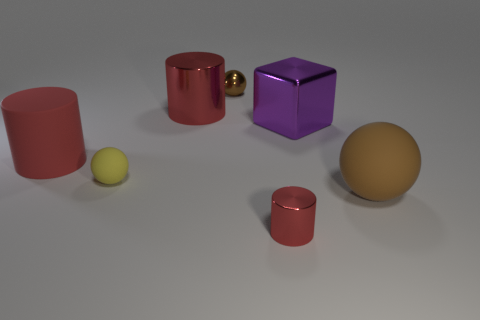Subtract all large red cylinders. How many cylinders are left? 1 Subtract all brown cylinders. How many brown spheres are left? 2 Add 1 metal things. How many objects exist? 8 Subtract all balls. How many objects are left? 4 Add 7 brown shiny objects. How many brown shiny objects are left? 8 Add 4 small matte balls. How many small matte balls exist? 5 Subtract 0 gray blocks. How many objects are left? 7 Subtract all blue cylinders. Subtract all blue balls. How many cylinders are left? 3 Subtract all big yellow shiny blocks. Subtract all small yellow spheres. How many objects are left? 6 